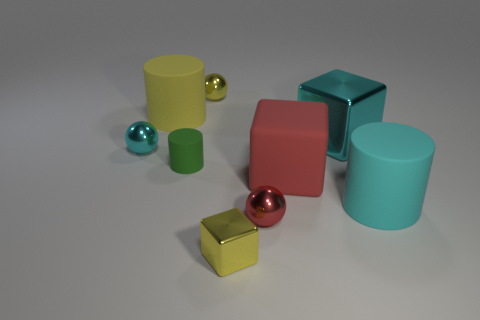There is a large cube that is made of the same material as the tiny cyan object; what color is it?
Your answer should be very brief. Cyan. There is a cyan object that is on the left side of the yellow ball; is its size the same as the big yellow cylinder?
Your answer should be very brief. No. The other big thing that is the same shape as the cyan matte thing is what color?
Give a very brief answer. Yellow. What shape is the small yellow shiny object that is to the left of the tiny object in front of the red object to the left of the large red matte cube?
Give a very brief answer. Sphere. Does the tiny red metal object have the same shape as the yellow rubber thing?
Offer a terse response. No. There is a large yellow matte thing on the left side of the small yellow object that is in front of the big cyan cylinder; what is its shape?
Offer a very short reply. Cylinder. Are there any green things?
Give a very brief answer. Yes. How many things are behind the tiny yellow thing that is in front of the shiny thing behind the yellow cylinder?
Your answer should be very brief. 8. Do the big red rubber thing and the cyan shiny thing that is left of the yellow metallic cube have the same shape?
Ensure brevity in your answer.  No. Is the number of big cyan matte cylinders greater than the number of large cyan shiny balls?
Provide a short and direct response. Yes. 